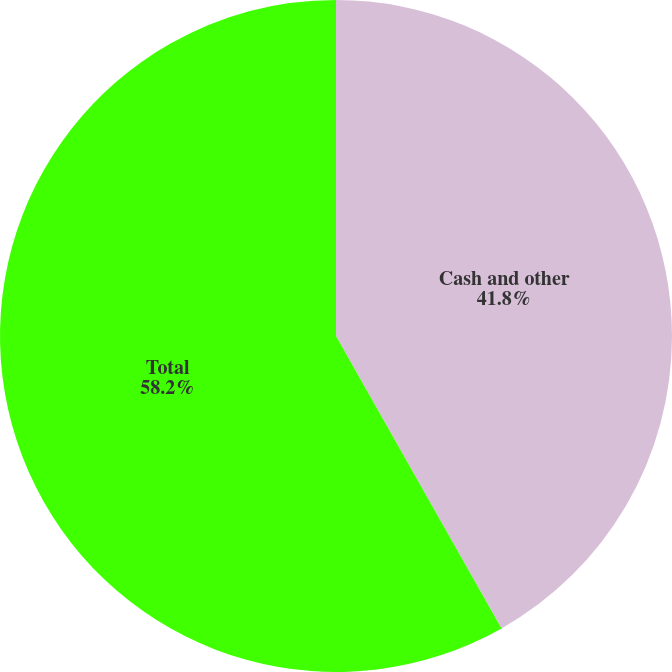<chart> <loc_0><loc_0><loc_500><loc_500><pie_chart><fcel>Cash and other<fcel>Total<nl><fcel>41.8%<fcel>58.2%<nl></chart> 